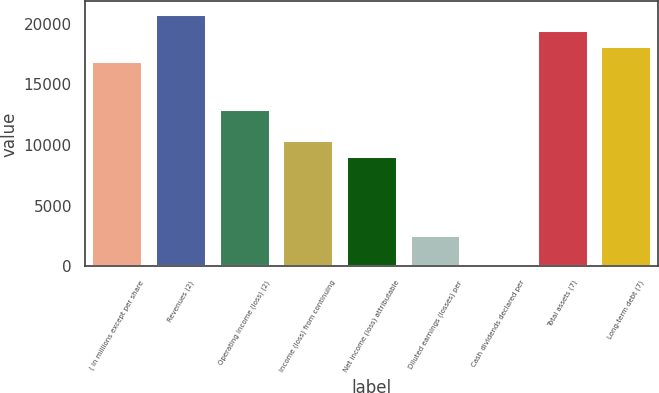Convert chart to OTSL. <chart><loc_0><loc_0><loc_500><loc_500><bar_chart><fcel>( in millions except per share<fcel>Revenues (2)<fcel>Operating income (loss) (2)<fcel>Income (loss) from continuing<fcel>Net income (loss) attributable<fcel>Diluted earnings (losses) per<fcel>Cash dividends declared per<fcel>Total assets (7)<fcel>Long-term debt (7)<nl><fcel>16886.9<fcel>20783.8<fcel>12990<fcel>10392<fcel>9093.07<fcel>2598.22<fcel>0.28<fcel>19484.8<fcel>18185.9<nl></chart> 